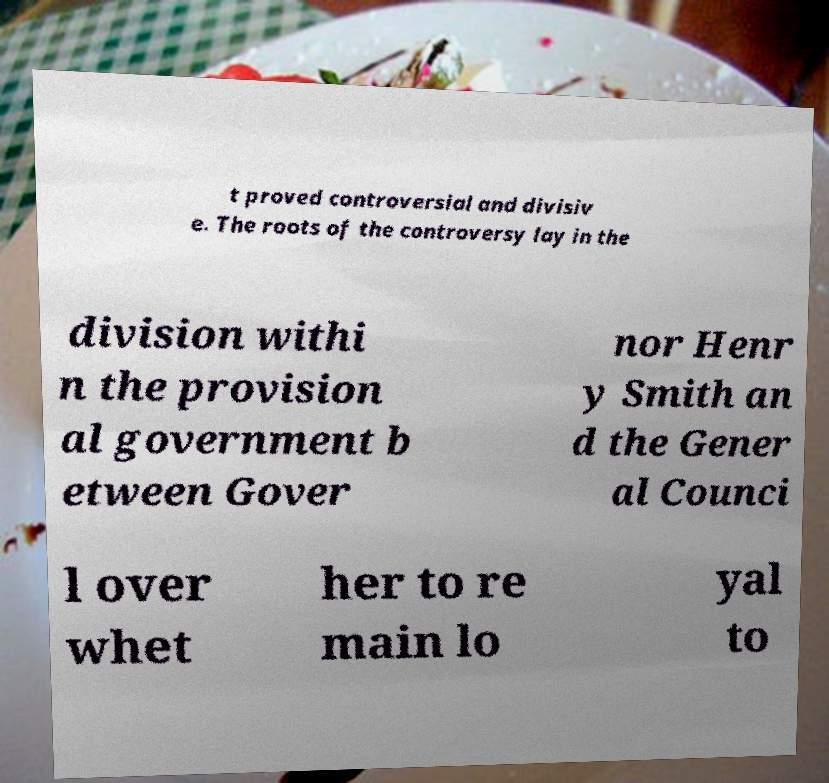Please read and relay the text visible in this image. What does it say? t proved controversial and divisiv e. The roots of the controversy lay in the division withi n the provision al government b etween Gover nor Henr y Smith an d the Gener al Counci l over whet her to re main lo yal to 